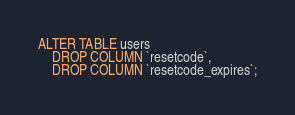Convert code to text. <code><loc_0><loc_0><loc_500><loc_500><_SQL_>ALTER TABLE users
    DROP COLUMN `resetcode`,
    DROP COLUMN `resetcode_expires`;
</code> 